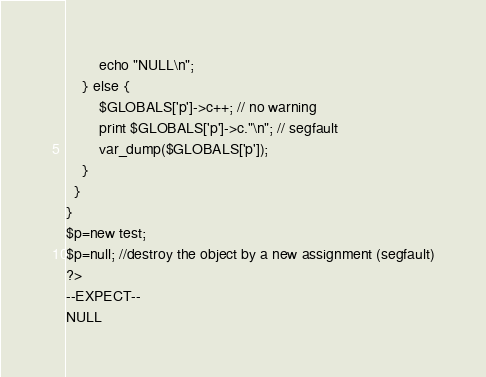Convert code to text. <code><loc_0><loc_0><loc_500><loc_500><_PHP_>        echo "NULL\n";
    } else {
        $GLOBALS['p']->c++; // no warning
        print $GLOBALS['p']->c."\n"; // segfault
        var_dump($GLOBALS['p']);
    }
  }
}
$p=new test;
$p=null; //destroy the object by a new assignment (segfault)
?>
--EXPECT--
NULL
</code> 